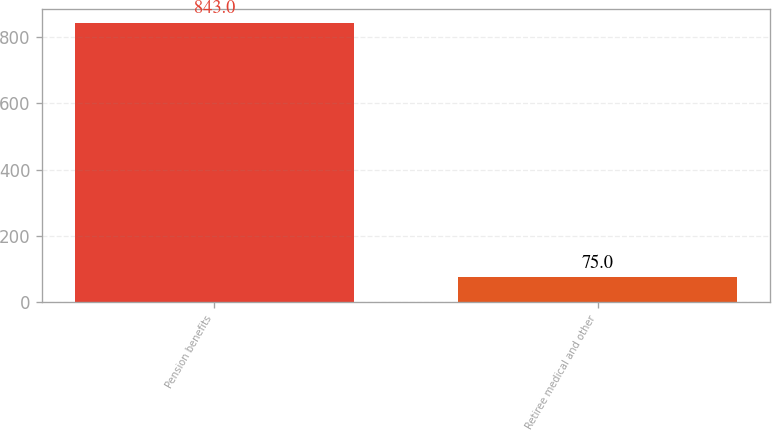Convert chart to OTSL. <chart><loc_0><loc_0><loc_500><loc_500><bar_chart><fcel>Pension benefits<fcel>Retiree medical and other<nl><fcel>843<fcel>75<nl></chart> 